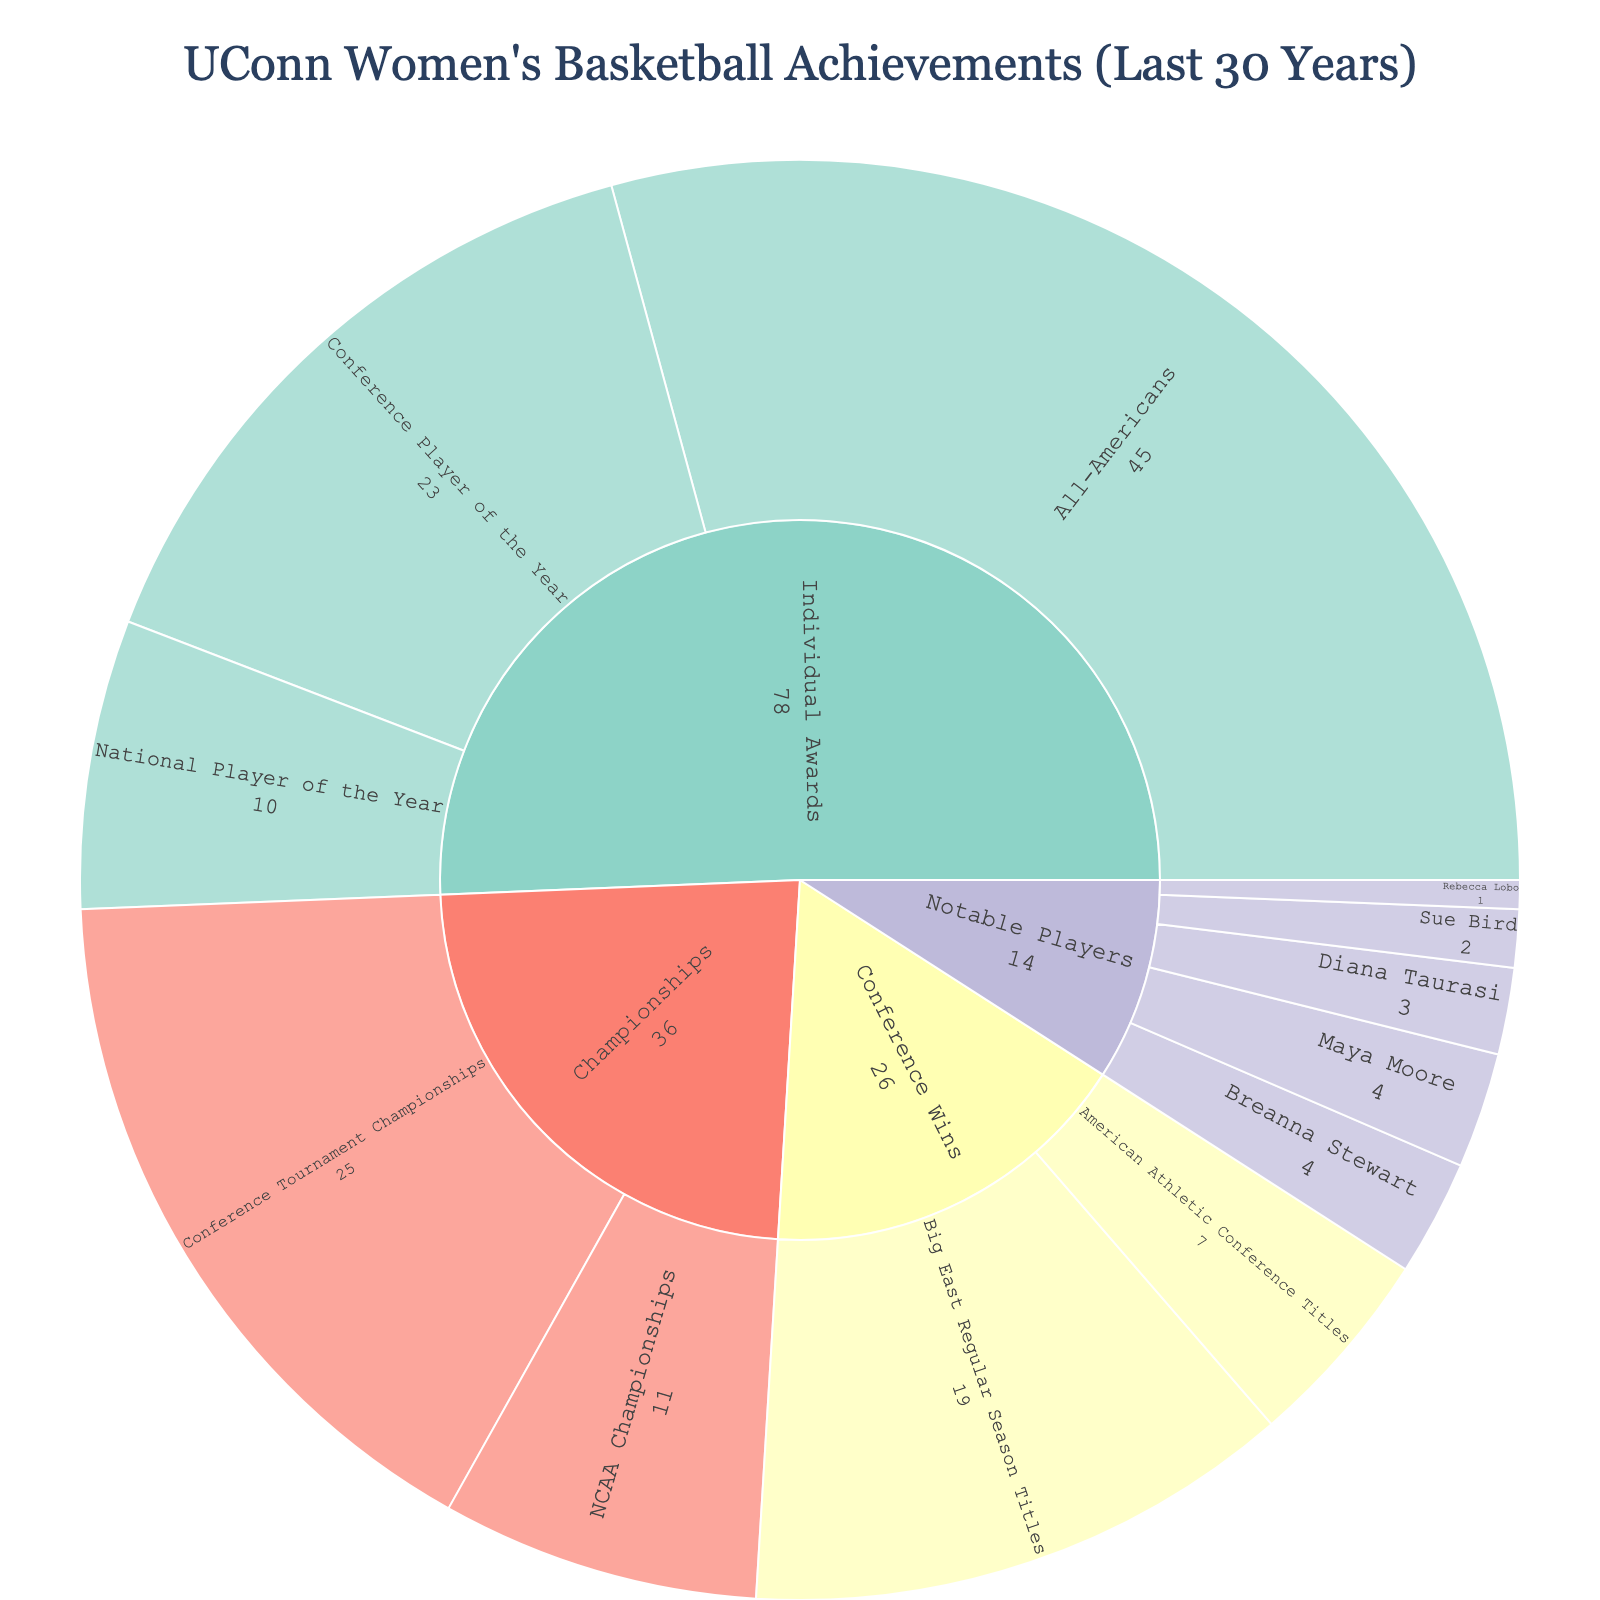What's the title of the plot? The title of the plot is often found at the top and usually provides a summary or the main focus of the chart. Here, it should describe the UConn Women's Basketball achievements.
Answer: UConn Women's Basketball Achievements (Last 30 Years) What category has the highest total value of achievements? To find this, sum all values under each main category (e.g., Championships, Conference Wins, Individual Awards). Championships have the largest items.
Answer: Championships How many NCAA Championships has UConn women’s basketball team won? The NCAA Championships value is visually represented as a segment under the Championships category.
Answer: 11 What is the sum of all achievements in the Individual Awards category? Add the values for National Player of the Year, Conference Player of the Year, and All-Americans, from the Individual Awards category.
Answer: (10+23+45)=78 Compare the number of All-Americans to Conference Player of the Year awards. Which is more, and by how much? Compare the values visually under the Individual Awards category and subtract the smaller value from the larger one.
Answer: All-Americans are more by 22 (45 - 23) Which notable player is mentioned with the highest number of achievements? Look under the Notable Players category and find which player has the largest segment value.
Answer: Maya Moore and Breanna Stewart (each with 4) What is the combined total of Big East Regular Season Titles and American Athletic Conference Titles? Add the values of these two segments under Conference Wins.
Answer: (19+7)=26 How does the number of Conference Tournament Championships compare to National Player of the Year awards? Find both values under their respective categories and compare them.
Answer: Conference Tournament Championships are more by 15 (25 - 10) What are the individual segments within the Championships category, and what are their values? Locate all subcategories directly under Championships and list their values.
Answer: NCAA Championships: 11, Conference Tournament Championships: 25 How many Notable Players are mentioned, and who are they? Count the segments under the Notable Players category and list their names.
Answer: Five players: Diana Taurasi, Maya Moore, Breanna Stewart, Sue Bird, Rebecca Lobo 